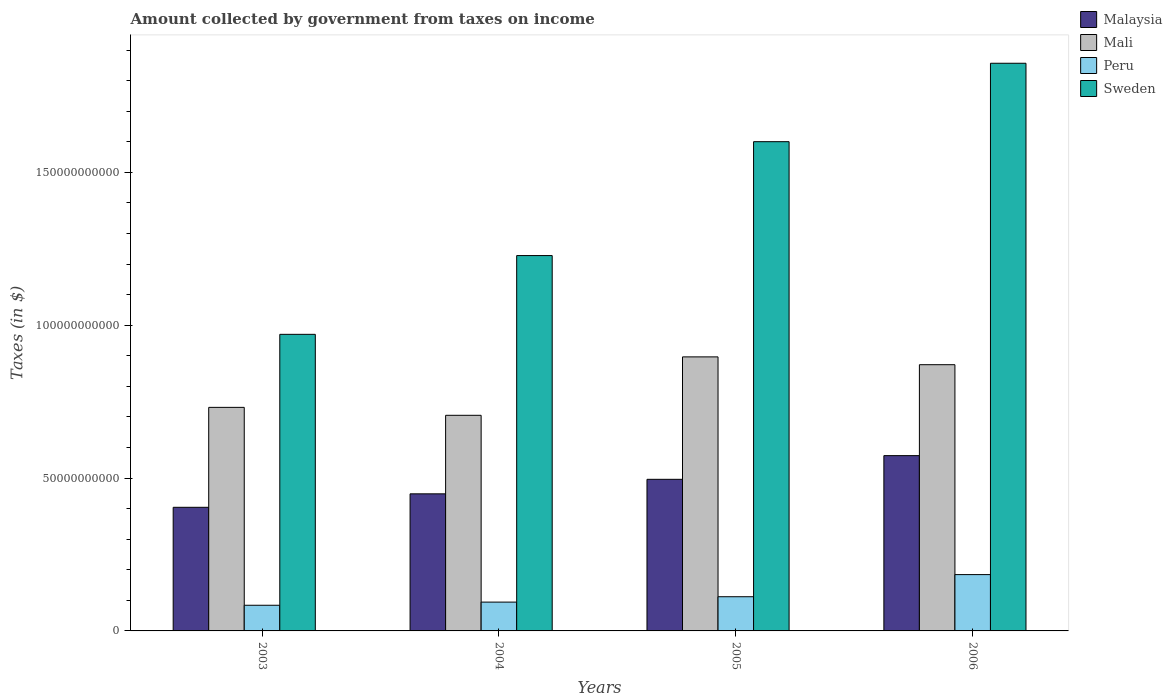What is the amount collected by government from taxes on income in Mali in 2005?
Offer a terse response. 8.96e+1. Across all years, what is the maximum amount collected by government from taxes on income in Malaysia?
Ensure brevity in your answer.  5.73e+1. Across all years, what is the minimum amount collected by government from taxes on income in Malaysia?
Your answer should be compact. 4.04e+1. In which year was the amount collected by government from taxes on income in Malaysia maximum?
Provide a short and direct response. 2006. What is the total amount collected by government from taxes on income in Malaysia in the graph?
Ensure brevity in your answer.  1.92e+11. What is the difference between the amount collected by government from taxes on income in Malaysia in 2004 and that in 2005?
Give a very brief answer. -4.75e+09. What is the difference between the amount collected by government from taxes on income in Sweden in 2003 and the amount collected by government from taxes on income in Peru in 2005?
Offer a terse response. 8.58e+1. What is the average amount collected by government from taxes on income in Peru per year?
Ensure brevity in your answer.  1.19e+1. In the year 2006, what is the difference between the amount collected by government from taxes on income in Malaysia and amount collected by government from taxes on income in Mali?
Ensure brevity in your answer.  -2.97e+1. In how many years, is the amount collected by government from taxes on income in Malaysia greater than 30000000000 $?
Your answer should be very brief. 4. What is the ratio of the amount collected by government from taxes on income in Peru in 2003 to that in 2004?
Offer a terse response. 0.89. Is the amount collected by government from taxes on income in Peru in 2003 less than that in 2006?
Your answer should be compact. Yes. What is the difference between the highest and the second highest amount collected by government from taxes on income in Malaysia?
Your answer should be very brief. 7.75e+09. What is the difference between the highest and the lowest amount collected by government from taxes on income in Mali?
Keep it short and to the point. 1.91e+1. In how many years, is the amount collected by government from taxes on income in Peru greater than the average amount collected by government from taxes on income in Peru taken over all years?
Ensure brevity in your answer.  1. Is the sum of the amount collected by government from taxes on income in Peru in 2003 and 2004 greater than the maximum amount collected by government from taxes on income in Malaysia across all years?
Offer a terse response. No. What does the 1st bar from the left in 2006 represents?
Your answer should be compact. Malaysia. What does the 4th bar from the right in 2006 represents?
Your answer should be compact. Malaysia. Is it the case that in every year, the sum of the amount collected by government from taxes on income in Sweden and amount collected by government from taxes on income in Malaysia is greater than the amount collected by government from taxes on income in Mali?
Your answer should be compact. Yes. How many bars are there?
Provide a succinct answer. 16. Are the values on the major ticks of Y-axis written in scientific E-notation?
Ensure brevity in your answer.  No. Does the graph contain any zero values?
Give a very brief answer. No. What is the title of the graph?
Your answer should be compact. Amount collected by government from taxes on income. Does "El Salvador" appear as one of the legend labels in the graph?
Your answer should be very brief. No. What is the label or title of the Y-axis?
Your response must be concise. Taxes (in $). What is the Taxes (in $) of Malaysia in 2003?
Your answer should be very brief. 4.04e+1. What is the Taxes (in $) in Mali in 2003?
Your answer should be compact. 7.31e+1. What is the Taxes (in $) of Peru in 2003?
Give a very brief answer. 8.40e+09. What is the Taxes (in $) in Sweden in 2003?
Give a very brief answer. 9.70e+1. What is the Taxes (in $) of Malaysia in 2004?
Your answer should be very brief. 4.48e+1. What is the Taxes (in $) of Mali in 2004?
Offer a terse response. 7.05e+1. What is the Taxes (in $) in Peru in 2004?
Offer a terse response. 9.43e+09. What is the Taxes (in $) of Sweden in 2004?
Provide a short and direct response. 1.23e+11. What is the Taxes (in $) in Malaysia in 2005?
Provide a succinct answer. 4.96e+1. What is the Taxes (in $) in Mali in 2005?
Your answer should be compact. 8.96e+1. What is the Taxes (in $) of Peru in 2005?
Offer a terse response. 1.12e+1. What is the Taxes (in $) in Sweden in 2005?
Offer a terse response. 1.60e+11. What is the Taxes (in $) of Malaysia in 2006?
Give a very brief answer. 5.73e+1. What is the Taxes (in $) in Mali in 2006?
Make the answer very short. 8.71e+1. What is the Taxes (in $) of Peru in 2006?
Provide a short and direct response. 1.84e+1. What is the Taxes (in $) of Sweden in 2006?
Offer a very short reply. 1.86e+11. Across all years, what is the maximum Taxes (in $) in Malaysia?
Provide a short and direct response. 5.73e+1. Across all years, what is the maximum Taxes (in $) in Mali?
Offer a very short reply. 8.96e+1. Across all years, what is the maximum Taxes (in $) in Peru?
Give a very brief answer. 1.84e+1. Across all years, what is the maximum Taxes (in $) in Sweden?
Offer a terse response. 1.86e+11. Across all years, what is the minimum Taxes (in $) in Malaysia?
Offer a very short reply. 4.04e+1. Across all years, what is the minimum Taxes (in $) in Mali?
Your response must be concise. 7.05e+1. Across all years, what is the minimum Taxes (in $) of Peru?
Provide a short and direct response. 8.40e+09. Across all years, what is the minimum Taxes (in $) of Sweden?
Ensure brevity in your answer.  9.70e+1. What is the total Taxes (in $) in Malaysia in the graph?
Offer a terse response. 1.92e+11. What is the total Taxes (in $) of Mali in the graph?
Make the answer very short. 3.20e+11. What is the total Taxes (in $) in Peru in the graph?
Make the answer very short. 4.74e+1. What is the total Taxes (in $) of Sweden in the graph?
Keep it short and to the point. 5.66e+11. What is the difference between the Taxes (in $) in Malaysia in 2003 and that in 2004?
Keep it short and to the point. -4.40e+09. What is the difference between the Taxes (in $) in Mali in 2003 and that in 2004?
Ensure brevity in your answer.  2.59e+09. What is the difference between the Taxes (in $) in Peru in 2003 and that in 2004?
Your answer should be compact. -1.03e+09. What is the difference between the Taxes (in $) in Sweden in 2003 and that in 2004?
Make the answer very short. -2.58e+1. What is the difference between the Taxes (in $) in Malaysia in 2003 and that in 2005?
Ensure brevity in your answer.  -9.16e+09. What is the difference between the Taxes (in $) in Mali in 2003 and that in 2005?
Ensure brevity in your answer.  -1.65e+1. What is the difference between the Taxes (in $) in Peru in 2003 and that in 2005?
Offer a terse response. -2.79e+09. What is the difference between the Taxes (in $) in Sweden in 2003 and that in 2005?
Your response must be concise. -6.30e+1. What is the difference between the Taxes (in $) in Malaysia in 2003 and that in 2006?
Your response must be concise. -1.69e+1. What is the difference between the Taxes (in $) of Mali in 2003 and that in 2006?
Offer a terse response. -1.40e+1. What is the difference between the Taxes (in $) of Peru in 2003 and that in 2006?
Make the answer very short. -1.00e+1. What is the difference between the Taxes (in $) in Sweden in 2003 and that in 2006?
Your answer should be compact. -8.87e+1. What is the difference between the Taxes (in $) in Malaysia in 2004 and that in 2005?
Give a very brief answer. -4.75e+09. What is the difference between the Taxes (in $) of Mali in 2004 and that in 2005?
Make the answer very short. -1.91e+1. What is the difference between the Taxes (in $) in Peru in 2004 and that in 2005?
Provide a short and direct response. -1.76e+09. What is the difference between the Taxes (in $) in Sweden in 2004 and that in 2005?
Give a very brief answer. -3.73e+1. What is the difference between the Taxes (in $) in Malaysia in 2004 and that in 2006?
Ensure brevity in your answer.  -1.25e+1. What is the difference between the Taxes (in $) in Mali in 2004 and that in 2006?
Offer a very short reply. -1.66e+1. What is the difference between the Taxes (in $) in Peru in 2004 and that in 2006?
Make the answer very short. -8.99e+09. What is the difference between the Taxes (in $) of Sweden in 2004 and that in 2006?
Offer a terse response. -6.29e+1. What is the difference between the Taxes (in $) in Malaysia in 2005 and that in 2006?
Your answer should be very brief. -7.75e+09. What is the difference between the Taxes (in $) in Mali in 2005 and that in 2006?
Your answer should be very brief. 2.55e+09. What is the difference between the Taxes (in $) in Peru in 2005 and that in 2006?
Ensure brevity in your answer.  -7.24e+09. What is the difference between the Taxes (in $) in Sweden in 2005 and that in 2006?
Your answer should be compact. -2.57e+1. What is the difference between the Taxes (in $) of Malaysia in 2003 and the Taxes (in $) of Mali in 2004?
Offer a very short reply. -3.01e+1. What is the difference between the Taxes (in $) of Malaysia in 2003 and the Taxes (in $) of Peru in 2004?
Provide a short and direct response. 3.10e+1. What is the difference between the Taxes (in $) of Malaysia in 2003 and the Taxes (in $) of Sweden in 2004?
Provide a short and direct response. -8.24e+1. What is the difference between the Taxes (in $) in Mali in 2003 and the Taxes (in $) in Peru in 2004?
Offer a very short reply. 6.37e+1. What is the difference between the Taxes (in $) of Mali in 2003 and the Taxes (in $) of Sweden in 2004?
Make the answer very short. -4.97e+1. What is the difference between the Taxes (in $) of Peru in 2003 and the Taxes (in $) of Sweden in 2004?
Provide a short and direct response. -1.14e+11. What is the difference between the Taxes (in $) of Malaysia in 2003 and the Taxes (in $) of Mali in 2005?
Your answer should be compact. -4.92e+1. What is the difference between the Taxes (in $) in Malaysia in 2003 and the Taxes (in $) in Peru in 2005?
Your answer should be very brief. 2.93e+1. What is the difference between the Taxes (in $) of Malaysia in 2003 and the Taxes (in $) of Sweden in 2005?
Your answer should be compact. -1.20e+11. What is the difference between the Taxes (in $) in Mali in 2003 and the Taxes (in $) in Peru in 2005?
Your answer should be very brief. 6.19e+1. What is the difference between the Taxes (in $) of Mali in 2003 and the Taxes (in $) of Sweden in 2005?
Ensure brevity in your answer.  -8.69e+1. What is the difference between the Taxes (in $) of Peru in 2003 and the Taxes (in $) of Sweden in 2005?
Ensure brevity in your answer.  -1.52e+11. What is the difference between the Taxes (in $) of Malaysia in 2003 and the Taxes (in $) of Mali in 2006?
Offer a terse response. -4.67e+1. What is the difference between the Taxes (in $) of Malaysia in 2003 and the Taxes (in $) of Peru in 2006?
Ensure brevity in your answer.  2.20e+1. What is the difference between the Taxes (in $) of Malaysia in 2003 and the Taxes (in $) of Sweden in 2006?
Your response must be concise. -1.45e+11. What is the difference between the Taxes (in $) in Mali in 2003 and the Taxes (in $) in Peru in 2006?
Provide a succinct answer. 5.47e+1. What is the difference between the Taxes (in $) of Mali in 2003 and the Taxes (in $) of Sweden in 2006?
Provide a succinct answer. -1.13e+11. What is the difference between the Taxes (in $) of Peru in 2003 and the Taxes (in $) of Sweden in 2006?
Your response must be concise. -1.77e+11. What is the difference between the Taxes (in $) of Malaysia in 2004 and the Taxes (in $) of Mali in 2005?
Provide a short and direct response. -4.48e+1. What is the difference between the Taxes (in $) of Malaysia in 2004 and the Taxes (in $) of Peru in 2005?
Provide a succinct answer. 3.37e+1. What is the difference between the Taxes (in $) of Malaysia in 2004 and the Taxes (in $) of Sweden in 2005?
Make the answer very short. -1.15e+11. What is the difference between the Taxes (in $) in Mali in 2004 and the Taxes (in $) in Peru in 2005?
Provide a succinct answer. 5.94e+1. What is the difference between the Taxes (in $) in Mali in 2004 and the Taxes (in $) in Sweden in 2005?
Give a very brief answer. -8.95e+1. What is the difference between the Taxes (in $) of Peru in 2004 and the Taxes (in $) of Sweden in 2005?
Provide a short and direct response. -1.51e+11. What is the difference between the Taxes (in $) in Malaysia in 2004 and the Taxes (in $) in Mali in 2006?
Offer a very short reply. -4.22e+1. What is the difference between the Taxes (in $) of Malaysia in 2004 and the Taxes (in $) of Peru in 2006?
Give a very brief answer. 2.64e+1. What is the difference between the Taxes (in $) in Malaysia in 2004 and the Taxes (in $) in Sweden in 2006?
Give a very brief answer. -1.41e+11. What is the difference between the Taxes (in $) of Mali in 2004 and the Taxes (in $) of Peru in 2006?
Your response must be concise. 5.21e+1. What is the difference between the Taxes (in $) in Mali in 2004 and the Taxes (in $) in Sweden in 2006?
Make the answer very short. -1.15e+11. What is the difference between the Taxes (in $) of Peru in 2004 and the Taxes (in $) of Sweden in 2006?
Provide a succinct answer. -1.76e+11. What is the difference between the Taxes (in $) of Malaysia in 2005 and the Taxes (in $) of Mali in 2006?
Your response must be concise. -3.75e+1. What is the difference between the Taxes (in $) in Malaysia in 2005 and the Taxes (in $) in Peru in 2006?
Your answer should be compact. 3.12e+1. What is the difference between the Taxes (in $) of Malaysia in 2005 and the Taxes (in $) of Sweden in 2006?
Give a very brief answer. -1.36e+11. What is the difference between the Taxes (in $) of Mali in 2005 and the Taxes (in $) of Peru in 2006?
Provide a succinct answer. 7.12e+1. What is the difference between the Taxes (in $) of Mali in 2005 and the Taxes (in $) of Sweden in 2006?
Provide a short and direct response. -9.61e+1. What is the difference between the Taxes (in $) in Peru in 2005 and the Taxes (in $) in Sweden in 2006?
Keep it short and to the point. -1.75e+11. What is the average Taxes (in $) of Malaysia per year?
Offer a very short reply. 4.81e+1. What is the average Taxes (in $) of Mali per year?
Your answer should be compact. 8.01e+1. What is the average Taxes (in $) in Peru per year?
Offer a terse response. 1.19e+1. What is the average Taxes (in $) in Sweden per year?
Your answer should be very brief. 1.41e+11. In the year 2003, what is the difference between the Taxes (in $) in Malaysia and Taxes (in $) in Mali?
Give a very brief answer. -3.27e+1. In the year 2003, what is the difference between the Taxes (in $) of Malaysia and Taxes (in $) of Peru?
Provide a succinct answer. 3.20e+1. In the year 2003, what is the difference between the Taxes (in $) in Malaysia and Taxes (in $) in Sweden?
Give a very brief answer. -5.66e+1. In the year 2003, what is the difference between the Taxes (in $) of Mali and Taxes (in $) of Peru?
Make the answer very short. 6.47e+1. In the year 2003, what is the difference between the Taxes (in $) of Mali and Taxes (in $) of Sweden?
Offer a very short reply. -2.39e+1. In the year 2003, what is the difference between the Taxes (in $) in Peru and Taxes (in $) in Sweden?
Your answer should be very brief. -8.86e+1. In the year 2004, what is the difference between the Taxes (in $) of Malaysia and Taxes (in $) of Mali?
Make the answer very short. -2.57e+1. In the year 2004, what is the difference between the Taxes (in $) in Malaysia and Taxes (in $) in Peru?
Offer a terse response. 3.54e+1. In the year 2004, what is the difference between the Taxes (in $) of Malaysia and Taxes (in $) of Sweden?
Give a very brief answer. -7.79e+1. In the year 2004, what is the difference between the Taxes (in $) of Mali and Taxes (in $) of Peru?
Offer a terse response. 6.11e+1. In the year 2004, what is the difference between the Taxes (in $) of Mali and Taxes (in $) of Sweden?
Offer a very short reply. -5.23e+1. In the year 2004, what is the difference between the Taxes (in $) of Peru and Taxes (in $) of Sweden?
Provide a short and direct response. -1.13e+11. In the year 2005, what is the difference between the Taxes (in $) in Malaysia and Taxes (in $) in Mali?
Ensure brevity in your answer.  -4.01e+1. In the year 2005, what is the difference between the Taxes (in $) in Malaysia and Taxes (in $) in Peru?
Your answer should be compact. 3.84e+1. In the year 2005, what is the difference between the Taxes (in $) of Malaysia and Taxes (in $) of Sweden?
Provide a succinct answer. -1.10e+11. In the year 2005, what is the difference between the Taxes (in $) of Mali and Taxes (in $) of Peru?
Give a very brief answer. 7.85e+1. In the year 2005, what is the difference between the Taxes (in $) of Mali and Taxes (in $) of Sweden?
Offer a very short reply. -7.04e+1. In the year 2005, what is the difference between the Taxes (in $) of Peru and Taxes (in $) of Sweden?
Your answer should be very brief. -1.49e+11. In the year 2006, what is the difference between the Taxes (in $) of Malaysia and Taxes (in $) of Mali?
Your response must be concise. -2.97e+1. In the year 2006, what is the difference between the Taxes (in $) in Malaysia and Taxes (in $) in Peru?
Your answer should be compact. 3.89e+1. In the year 2006, what is the difference between the Taxes (in $) in Malaysia and Taxes (in $) in Sweden?
Your response must be concise. -1.28e+11. In the year 2006, what is the difference between the Taxes (in $) in Mali and Taxes (in $) in Peru?
Your answer should be compact. 6.87e+1. In the year 2006, what is the difference between the Taxes (in $) of Mali and Taxes (in $) of Sweden?
Make the answer very short. -9.86e+1. In the year 2006, what is the difference between the Taxes (in $) of Peru and Taxes (in $) of Sweden?
Give a very brief answer. -1.67e+11. What is the ratio of the Taxes (in $) in Malaysia in 2003 to that in 2004?
Offer a very short reply. 0.9. What is the ratio of the Taxes (in $) of Mali in 2003 to that in 2004?
Make the answer very short. 1.04. What is the ratio of the Taxes (in $) in Peru in 2003 to that in 2004?
Your answer should be very brief. 0.89. What is the ratio of the Taxes (in $) of Sweden in 2003 to that in 2004?
Provide a succinct answer. 0.79. What is the ratio of the Taxes (in $) of Malaysia in 2003 to that in 2005?
Your response must be concise. 0.82. What is the ratio of the Taxes (in $) in Mali in 2003 to that in 2005?
Your response must be concise. 0.82. What is the ratio of the Taxes (in $) of Peru in 2003 to that in 2005?
Keep it short and to the point. 0.75. What is the ratio of the Taxes (in $) in Sweden in 2003 to that in 2005?
Keep it short and to the point. 0.61. What is the ratio of the Taxes (in $) of Malaysia in 2003 to that in 2006?
Ensure brevity in your answer.  0.71. What is the ratio of the Taxes (in $) in Mali in 2003 to that in 2006?
Keep it short and to the point. 0.84. What is the ratio of the Taxes (in $) in Peru in 2003 to that in 2006?
Keep it short and to the point. 0.46. What is the ratio of the Taxes (in $) of Sweden in 2003 to that in 2006?
Keep it short and to the point. 0.52. What is the ratio of the Taxes (in $) in Malaysia in 2004 to that in 2005?
Ensure brevity in your answer.  0.9. What is the ratio of the Taxes (in $) in Mali in 2004 to that in 2005?
Make the answer very short. 0.79. What is the ratio of the Taxes (in $) of Peru in 2004 to that in 2005?
Make the answer very short. 0.84. What is the ratio of the Taxes (in $) in Sweden in 2004 to that in 2005?
Your answer should be very brief. 0.77. What is the ratio of the Taxes (in $) in Malaysia in 2004 to that in 2006?
Make the answer very short. 0.78. What is the ratio of the Taxes (in $) in Mali in 2004 to that in 2006?
Make the answer very short. 0.81. What is the ratio of the Taxes (in $) in Peru in 2004 to that in 2006?
Ensure brevity in your answer.  0.51. What is the ratio of the Taxes (in $) of Sweden in 2004 to that in 2006?
Give a very brief answer. 0.66. What is the ratio of the Taxes (in $) of Malaysia in 2005 to that in 2006?
Offer a very short reply. 0.86. What is the ratio of the Taxes (in $) of Mali in 2005 to that in 2006?
Your answer should be compact. 1.03. What is the ratio of the Taxes (in $) in Peru in 2005 to that in 2006?
Your answer should be very brief. 0.61. What is the ratio of the Taxes (in $) of Sweden in 2005 to that in 2006?
Provide a short and direct response. 0.86. What is the difference between the highest and the second highest Taxes (in $) of Malaysia?
Your answer should be compact. 7.75e+09. What is the difference between the highest and the second highest Taxes (in $) in Mali?
Offer a terse response. 2.55e+09. What is the difference between the highest and the second highest Taxes (in $) in Peru?
Your response must be concise. 7.24e+09. What is the difference between the highest and the second highest Taxes (in $) of Sweden?
Offer a terse response. 2.57e+1. What is the difference between the highest and the lowest Taxes (in $) in Malaysia?
Provide a succinct answer. 1.69e+1. What is the difference between the highest and the lowest Taxes (in $) in Mali?
Ensure brevity in your answer.  1.91e+1. What is the difference between the highest and the lowest Taxes (in $) of Peru?
Ensure brevity in your answer.  1.00e+1. What is the difference between the highest and the lowest Taxes (in $) of Sweden?
Provide a short and direct response. 8.87e+1. 